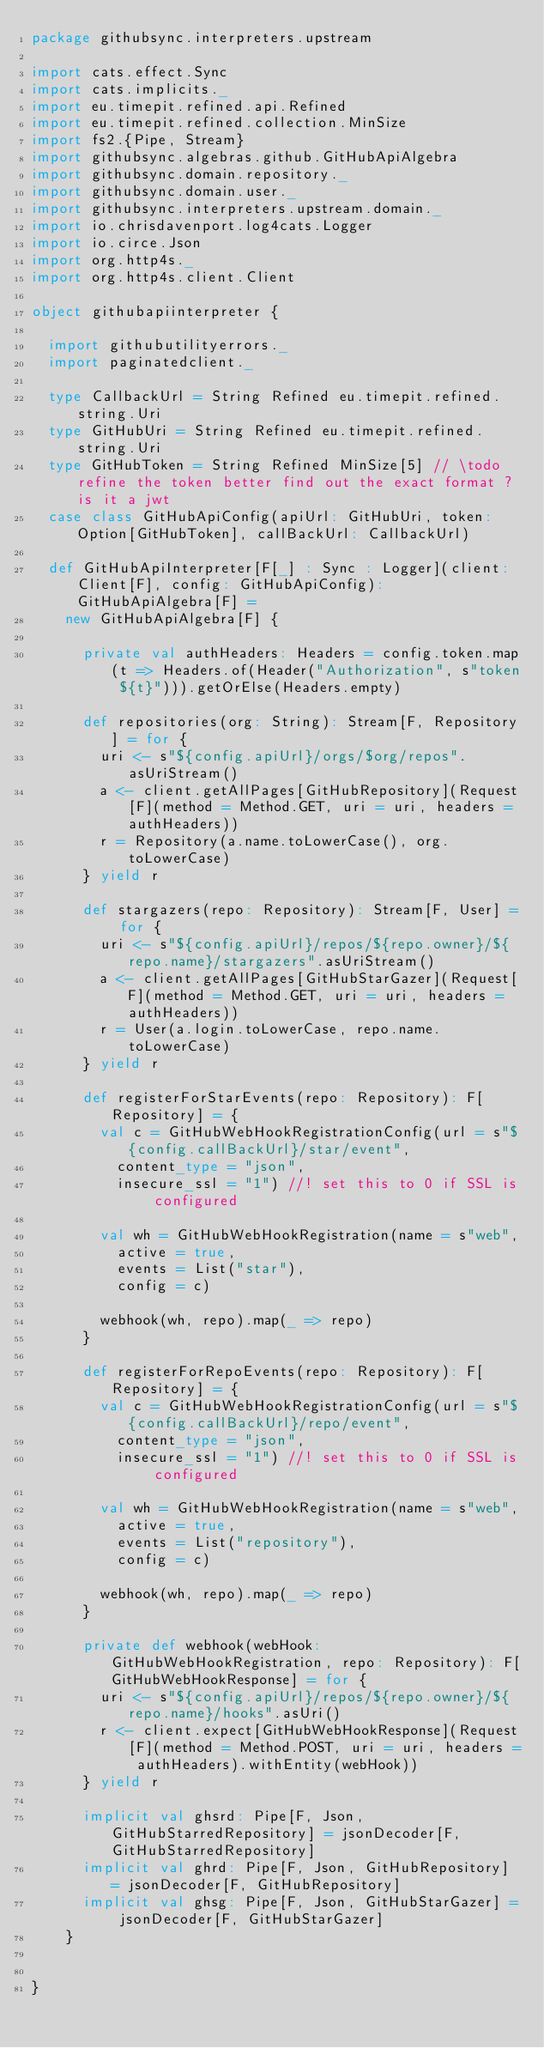Convert code to text. <code><loc_0><loc_0><loc_500><loc_500><_Scala_>package githubsync.interpreters.upstream

import cats.effect.Sync
import cats.implicits._
import eu.timepit.refined.api.Refined
import eu.timepit.refined.collection.MinSize
import fs2.{Pipe, Stream}
import githubsync.algebras.github.GitHubApiAlgebra
import githubsync.domain.repository._
import githubsync.domain.user._
import githubsync.interpreters.upstream.domain._
import io.chrisdavenport.log4cats.Logger
import io.circe.Json
import org.http4s._
import org.http4s.client.Client

object githubapiinterpreter {

  import githubutilityerrors._
  import paginatedclient._

  type CallbackUrl = String Refined eu.timepit.refined.string.Uri
  type GitHubUri = String Refined eu.timepit.refined.string.Uri
  type GitHubToken = String Refined MinSize[5] // \todo refine the token better find out the exact format ? is it a jwt
  case class GitHubApiConfig(apiUrl: GitHubUri, token: Option[GitHubToken], callBackUrl: CallbackUrl)

  def GitHubApiInterpreter[F[_] : Sync : Logger](client: Client[F], config: GitHubApiConfig): GitHubApiAlgebra[F] =
    new GitHubApiAlgebra[F] {

      private val authHeaders: Headers = config.token.map(t => Headers.of(Header("Authorization", s"token ${t}"))).getOrElse(Headers.empty)

      def repositories(org: String): Stream[F, Repository] = for {
        uri <- s"${config.apiUrl}/orgs/$org/repos".asUriStream()
        a <- client.getAllPages[GitHubRepository](Request[F](method = Method.GET, uri = uri, headers = authHeaders))
        r = Repository(a.name.toLowerCase(), org.toLowerCase)
      } yield r

      def stargazers(repo: Repository): Stream[F, User] = for {
        uri <- s"${config.apiUrl}/repos/${repo.owner}/${repo.name}/stargazers".asUriStream()
        a <- client.getAllPages[GitHubStarGazer](Request[F](method = Method.GET, uri = uri, headers = authHeaders))
        r = User(a.login.toLowerCase, repo.name.toLowerCase)
      } yield r

      def registerForStarEvents(repo: Repository): F[Repository] = {
        val c = GitHubWebHookRegistrationConfig(url = s"${config.callBackUrl}/star/event",
          content_type = "json",
          insecure_ssl = "1") //! set this to 0 if SSL is configured

        val wh = GitHubWebHookRegistration(name = s"web",
          active = true,
          events = List("star"),
          config = c)

        webhook(wh, repo).map(_ => repo)
      }

      def registerForRepoEvents(repo: Repository): F[Repository] = {
        val c = GitHubWebHookRegistrationConfig(url = s"${config.callBackUrl}/repo/event",
          content_type = "json",
          insecure_ssl = "1") //! set this to 0 if SSL is configured

        val wh = GitHubWebHookRegistration(name = s"web",
          active = true,
          events = List("repository"),
          config = c)

        webhook(wh, repo).map(_ => repo)
      }

      private def webhook(webHook: GitHubWebHookRegistration, repo: Repository): F[GitHubWebHookResponse] = for {
        uri <- s"${config.apiUrl}/repos/${repo.owner}/${repo.name}/hooks".asUri()
        r <- client.expect[GitHubWebHookResponse](Request[F](method = Method.POST, uri = uri, headers = authHeaders).withEntity(webHook))
      } yield r

      implicit val ghsrd: Pipe[F, Json, GitHubStarredRepository] = jsonDecoder[F, GitHubStarredRepository]
      implicit val ghrd: Pipe[F, Json, GitHubRepository] = jsonDecoder[F, GitHubRepository]
      implicit val ghsg: Pipe[F, Json, GitHubStarGazer] = jsonDecoder[F, GitHubStarGazer]
    }


}
</code> 